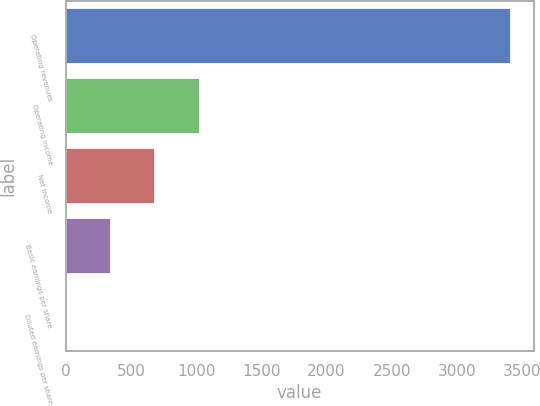<chart> <loc_0><loc_0><loc_500><loc_500><bar_chart><fcel>Operating revenues<fcel>Operating income<fcel>Net income<fcel>Basic earnings per share<fcel>Diluted earnings per share<nl><fcel>3417<fcel>1026.24<fcel>684.7<fcel>343.16<fcel>1.62<nl></chart> 